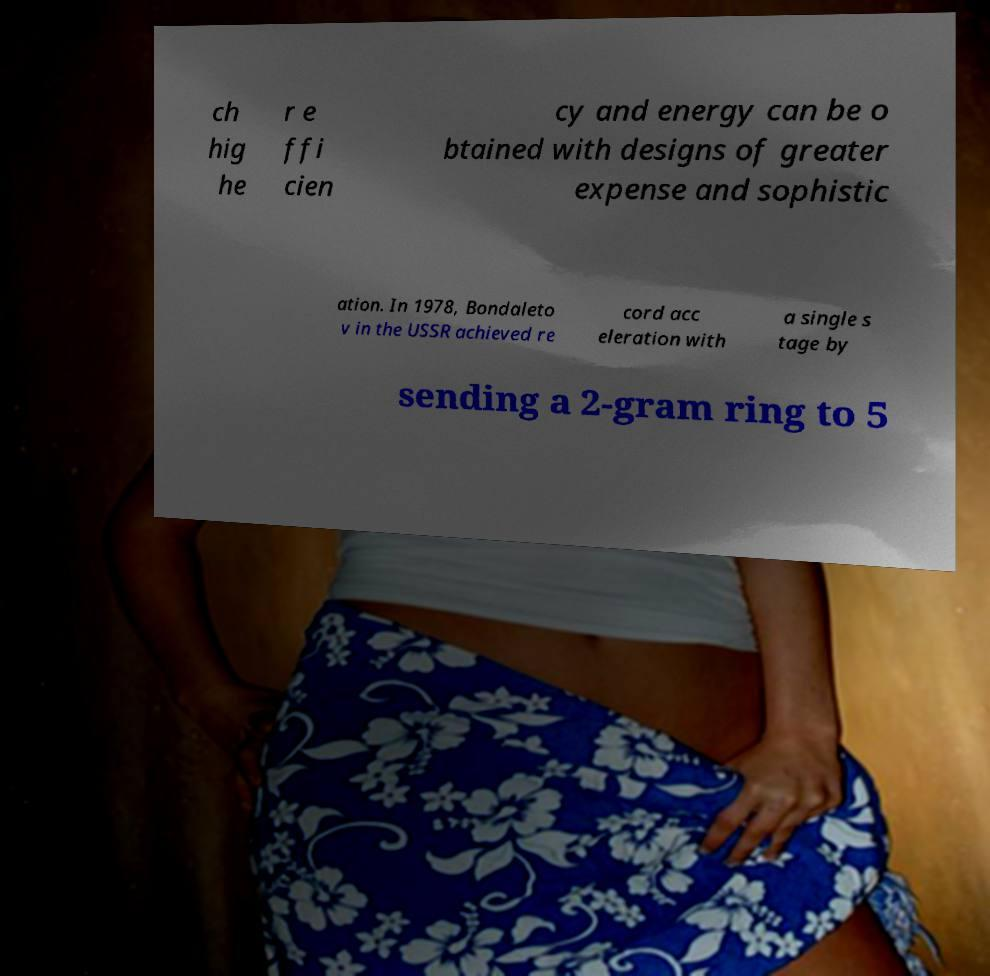I need the written content from this picture converted into text. Can you do that? ch hig he r e ffi cien cy and energy can be o btained with designs of greater expense and sophistic ation. In 1978, Bondaleto v in the USSR achieved re cord acc eleration with a single s tage by sending a 2-gram ring to 5 